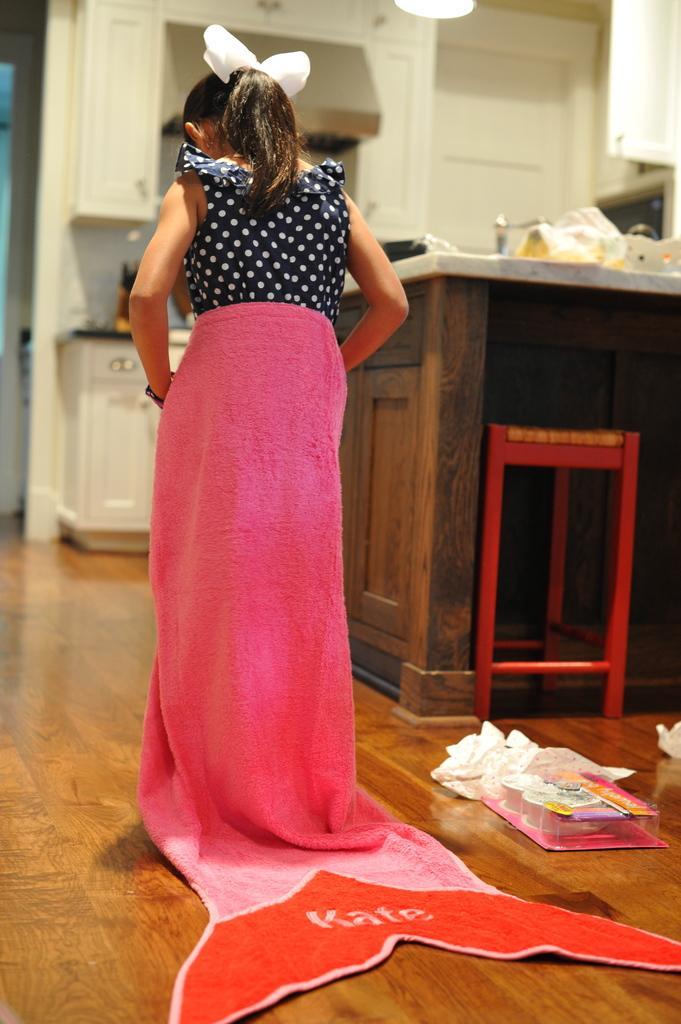Please provide a concise description of this image. In this picture there is a girl wearing pink color towel, standing in the kitchen. Behind we can see the table. In the background there is a white color door. 